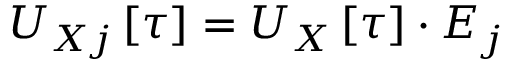Convert formula to latex. <formula><loc_0><loc_0><loc_500><loc_500>U _ { X j } \left [ \tau \right ] = U _ { \ u { X } } \left [ \tau \right ] \cdot E _ { j }</formula> 